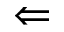Convert formula to latex. <formula><loc_0><loc_0><loc_500><loc_500>\Leftarrow</formula> 